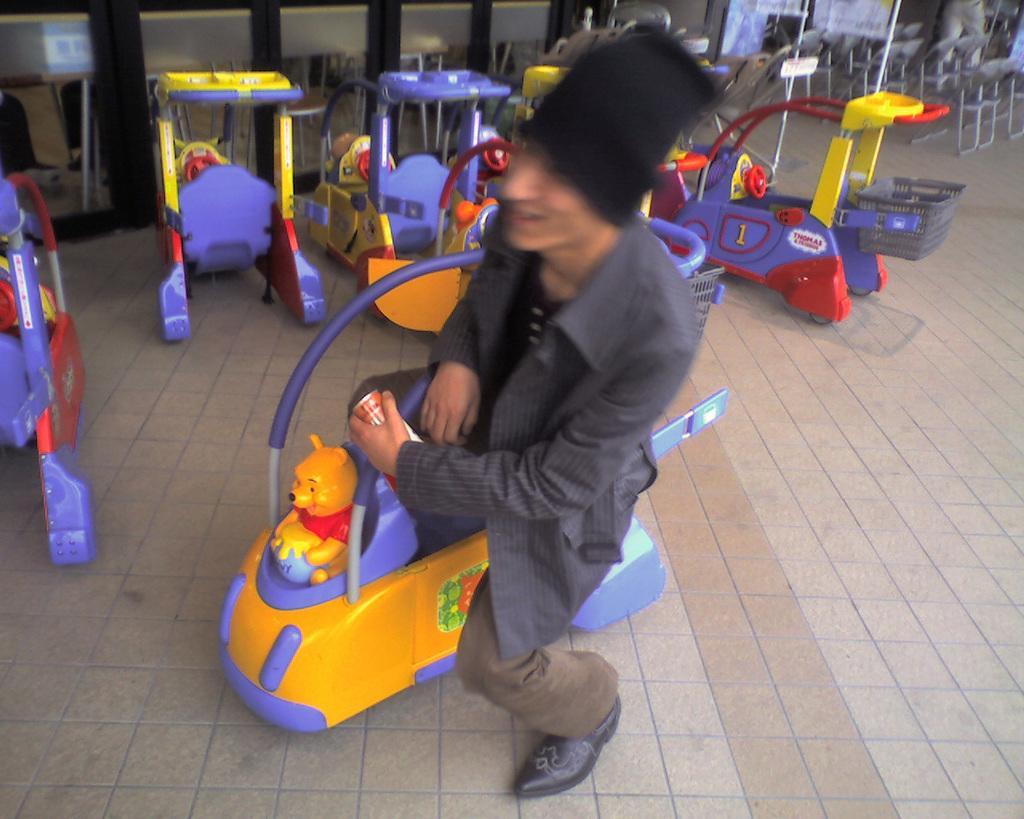Could you give a brief overview of what you see in this image? In this picture, there is a person sitting on the toy vehicle. He is wearing a blazer and trousers. In the background, there are few more toy vehicles. On the top right, there are chairs which are in grey in color. 